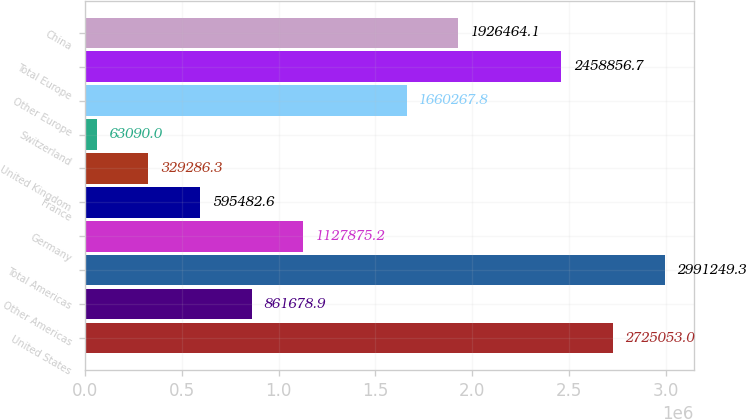Convert chart to OTSL. <chart><loc_0><loc_0><loc_500><loc_500><bar_chart><fcel>United States<fcel>Other Americas<fcel>Total Americas<fcel>Germany<fcel>France<fcel>United Kingdom<fcel>Switzerland<fcel>Other Europe<fcel>Total Europe<fcel>China<nl><fcel>2.72505e+06<fcel>861679<fcel>2.99125e+06<fcel>1.12788e+06<fcel>595483<fcel>329286<fcel>63090<fcel>1.66027e+06<fcel>2.45886e+06<fcel>1.92646e+06<nl></chart> 